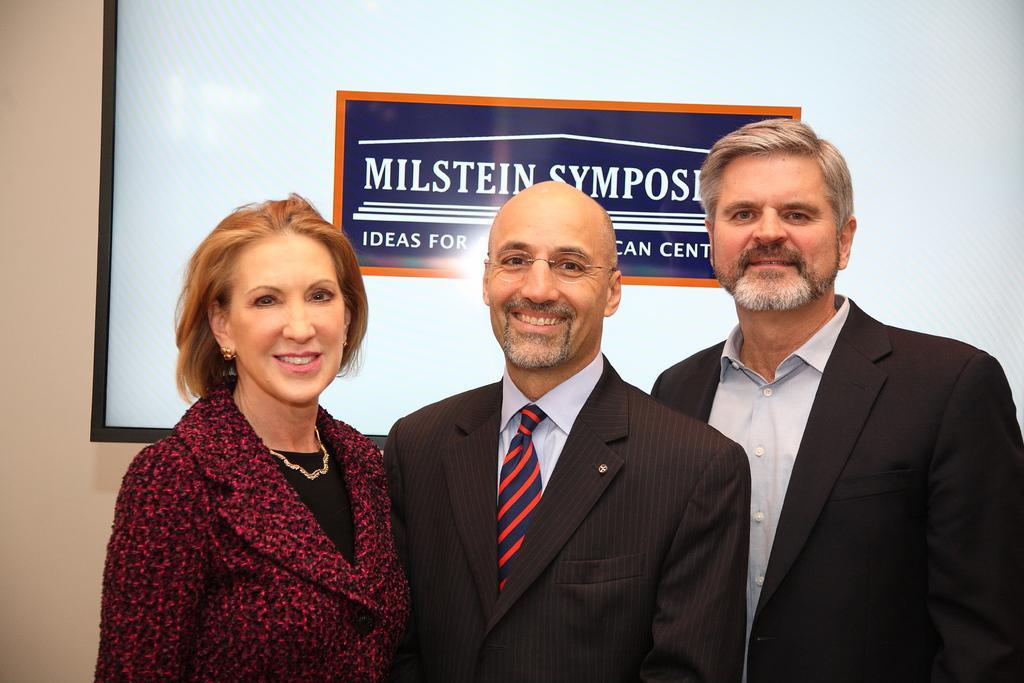How would you summarize this image in a sentence or two? In this image I can see two men wearing blazers and a woman are standing and smiling. In the background I can see the wall and a huge board attached to the wall. 